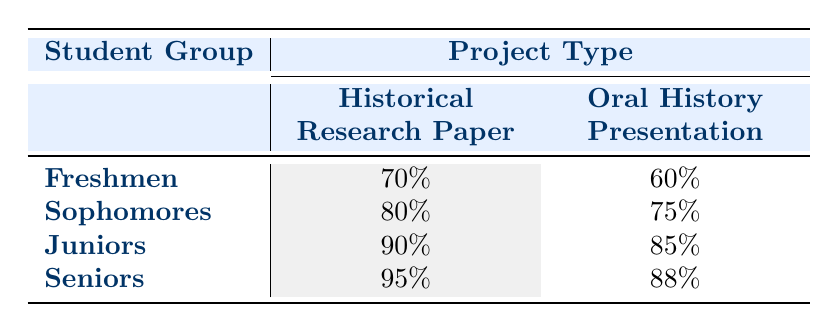What is the success rate for Seniors in Historical Research Paper? The table shows the success rate for Seniors under the project type "Historical Research Paper" is 95%.
Answer: 95% Which student group has the highest success rate in Oral History Presentation? In the table, the success rates for Oral History Presentation are 60% (Freshmen), 75% (Sophomores), 85% (Juniors), and 88% (Seniors). The highest is 88% for Seniors.
Answer: Seniors What is the average success rate for Juniors across both project types? For Juniors, the success rates are 90% (Historical Research Paper) and 85% (Oral History Presentation). Adding these gives 90 + 85 = 175. Dividing this by 2 gives an average of 175 / 2 = 87.5.
Answer: 87.5 Do Sophomores have a higher success rate in Historical Research Paper compared to Freshmen? The success rate for Sophomores in Historical Research Paper is 80%, while for Freshmen it is 70%. Since 80% > 70%, the statement is true.
Answer: Yes If we compare the difference in success rates for Oral History Presentation between Freshmen and Seniors, what is the result? Freshmen have a success rate of 60% and Seniors have 88% in Oral History Presentation. The difference is 88 - 60 = 28%.
Answer: 28% What is the total success rate for all student groups in Historical Research Paper? The success rates for Historical Research Paper are 70% (Freshmen), 80% (Sophomores), 90% (Juniors), and 95% (Seniors). Adding these gives: 70 + 80 + 90 + 95 = 335%.
Answer: 335% Can we say that all student groups have a success rate above 60% in Historical Research Paper? The success rates are 70% (Freshmen), 80% (Sophomores), 90% (Juniors), and 95% (Seniors), which are all above 60%. Therefore, the statement is true.
Answer: Yes What’s the lowest success rate among all project types in the table? The lowest success rate among the displayed projects is for Freshmen in Oral History Presentation, which is 60%.
Answer: 60% 